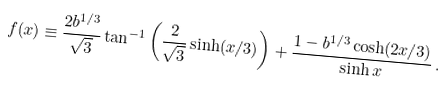Convert formula to latex. <formula><loc_0><loc_0><loc_500><loc_500>f ( x ) \equiv \frac { 2 b ^ { 1 / 3 } } { \sqrt { 3 } } \tan ^ { - 1 } \left ( \frac { 2 } { \sqrt { 3 } } \sinh ( x / 3 ) \right ) + \frac { 1 - b ^ { 1 / 3 } \cosh ( 2 x / 3 ) } { \sinh x } \, .</formula> 